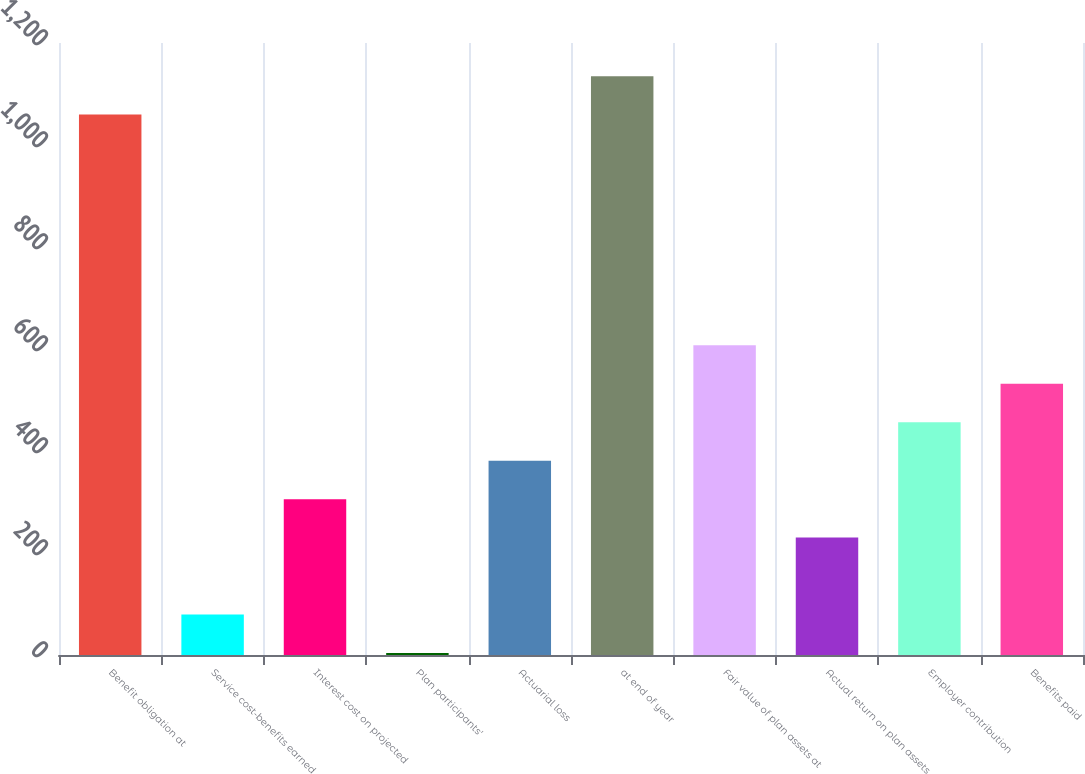Convert chart. <chart><loc_0><loc_0><loc_500><loc_500><bar_chart><fcel>Benefit obligation at<fcel>Service cost-benefits earned<fcel>Interest cost on projected<fcel>Plan participants'<fcel>Actuarial loss<fcel>at end of year<fcel>Fair value of plan assets at<fcel>Actual return on plan assets<fcel>Employer contribution<fcel>Benefits paid<nl><fcel>1059.6<fcel>79.4<fcel>305.6<fcel>4<fcel>381<fcel>1135<fcel>607.2<fcel>230.2<fcel>456.4<fcel>531.8<nl></chart> 